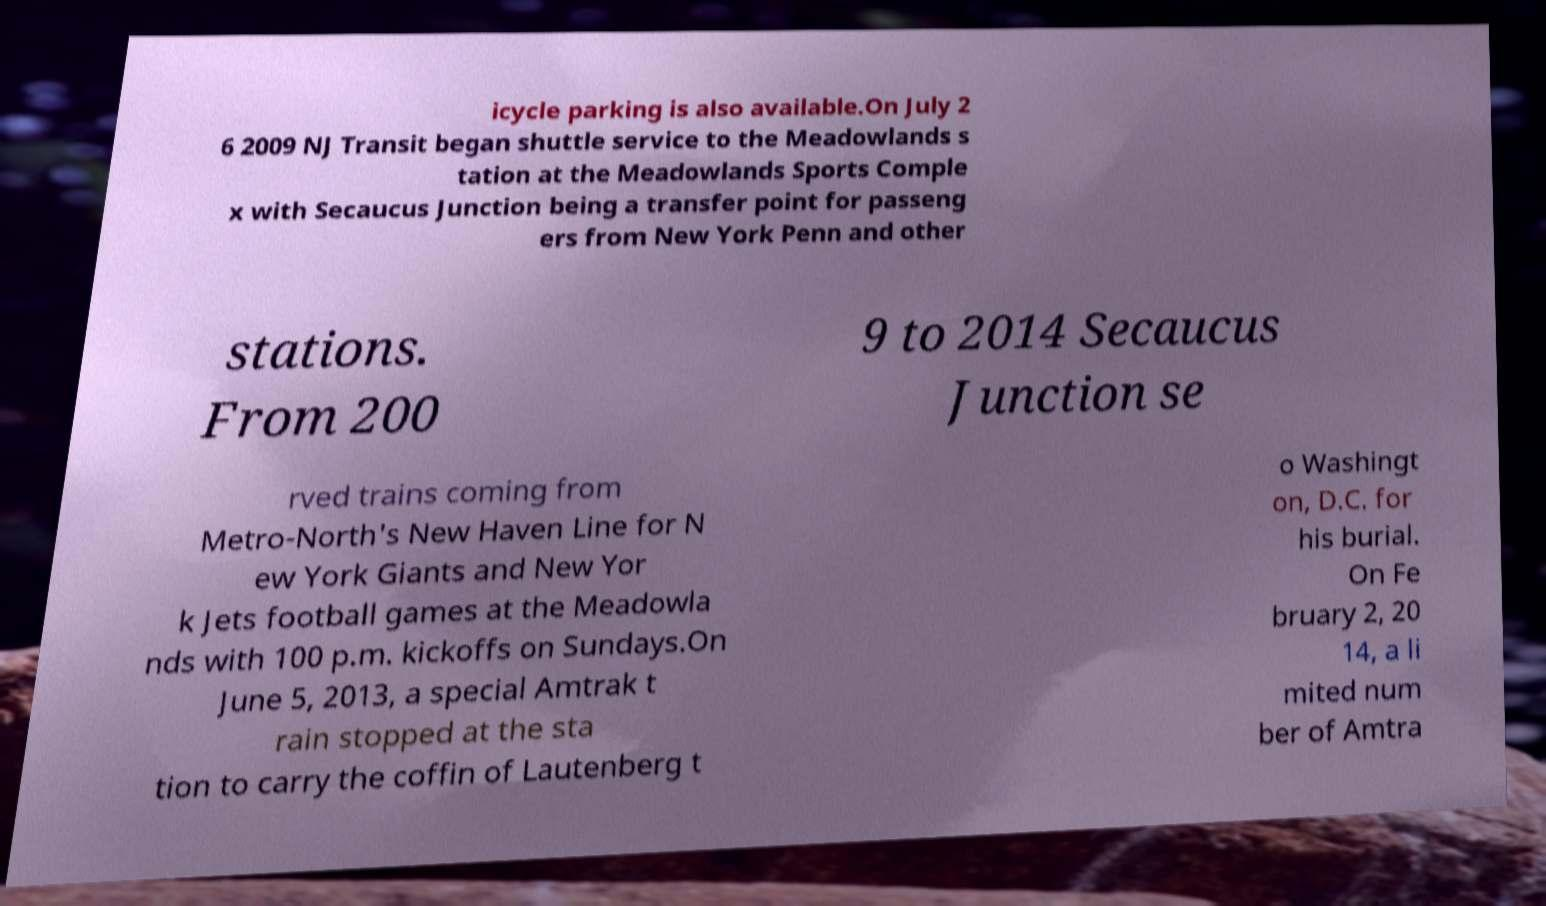Could you assist in decoding the text presented in this image and type it out clearly? icycle parking is also available.On July 2 6 2009 NJ Transit began shuttle service to the Meadowlands s tation at the Meadowlands Sports Comple x with Secaucus Junction being a transfer point for passeng ers from New York Penn and other stations. From 200 9 to 2014 Secaucus Junction se rved trains coming from Metro-North's New Haven Line for N ew York Giants and New Yor k Jets football games at the Meadowla nds with 100 p.m. kickoffs on Sundays.On June 5, 2013, a special Amtrak t rain stopped at the sta tion to carry the coffin of Lautenberg t o Washingt on, D.C. for his burial. On Fe bruary 2, 20 14, a li mited num ber of Amtra 